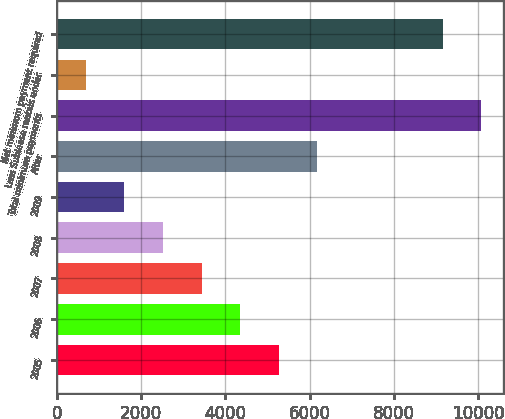<chart> <loc_0><loc_0><loc_500><loc_500><bar_chart><fcel>2005<fcel>2006<fcel>2007<fcel>2008<fcel>2009<fcel>After<fcel>Total minimum payments<fcel>Less Sublease rentals under<fcel>Net minimum payment required<nl><fcel>5271<fcel>4354.6<fcel>3438.2<fcel>2521.8<fcel>1605.4<fcel>6187.4<fcel>10080.4<fcel>689<fcel>9164<nl></chart> 